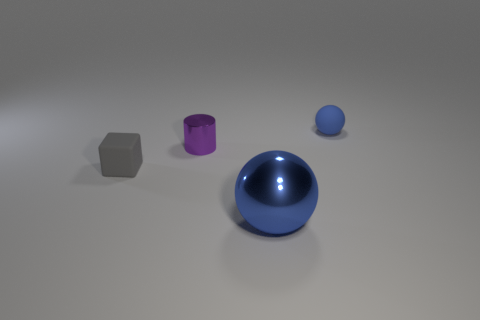Is there anything else that is the same size as the blue metal thing?
Give a very brief answer. No. What is the size of the blue sphere that is the same material as the small purple cylinder?
Give a very brief answer. Large. How big is the sphere to the left of the blue object behind the cube?
Give a very brief answer. Large. What is the small gray cube made of?
Offer a very short reply. Rubber. Is there a big metallic ball?
Ensure brevity in your answer.  Yes. Are there an equal number of spheres to the right of the blue shiny thing and blue rubber spheres?
Offer a terse response. Yes. What number of big things are either matte cubes or cylinders?
Your response must be concise. 0. What is the shape of the tiny object that is the same color as the big thing?
Offer a terse response. Sphere. Is the material of the ball left of the tiny matte ball the same as the small purple cylinder?
Make the answer very short. Yes. The small object in front of the metal thing that is on the left side of the metallic sphere is made of what material?
Offer a very short reply. Rubber. 